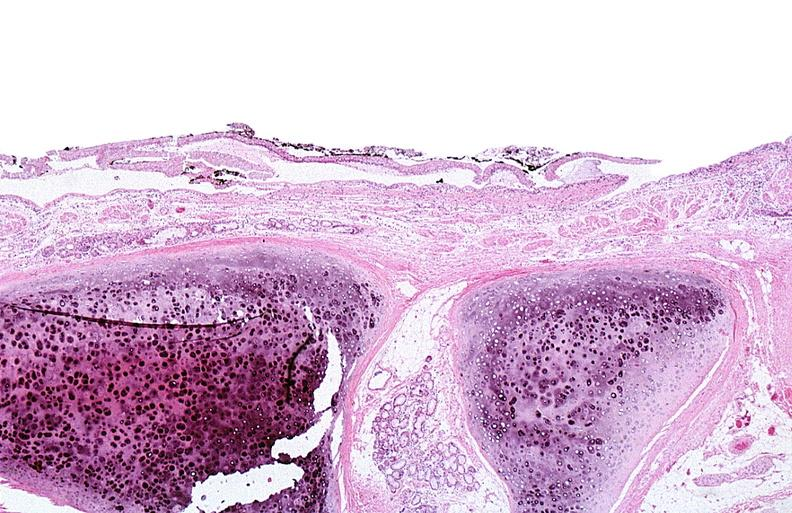does parathyroid show thermal burned skin?
Answer the question using a single word or phrase. No 